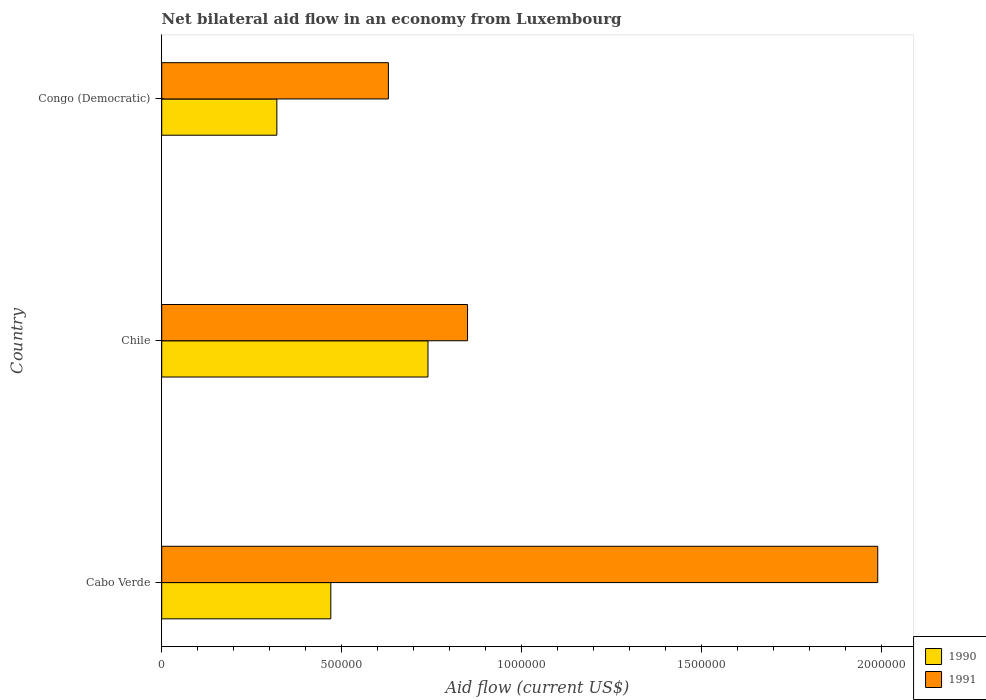How many different coloured bars are there?
Offer a very short reply. 2. How many groups of bars are there?
Your answer should be very brief. 3. How many bars are there on the 3rd tick from the bottom?
Keep it short and to the point. 2. What is the label of the 1st group of bars from the top?
Give a very brief answer. Congo (Democratic). What is the net bilateral aid flow in 1990 in Congo (Democratic)?
Your response must be concise. 3.20e+05. Across all countries, what is the maximum net bilateral aid flow in 1990?
Your answer should be very brief. 7.40e+05. Across all countries, what is the minimum net bilateral aid flow in 1990?
Ensure brevity in your answer.  3.20e+05. In which country was the net bilateral aid flow in 1991 maximum?
Offer a very short reply. Cabo Verde. In which country was the net bilateral aid flow in 1990 minimum?
Ensure brevity in your answer.  Congo (Democratic). What is the total net bilateral aid flow in 1990 in the graph?
Keep it short and to the point. 1.53e+06. What is the difference between the net bilateral aid flow in 1991 in Chile and that in Congo (Democratic)?
Your answer should be compact. 2.20e+05. What is the difference between the net bilateral aid flow in 1991 in Chile and the net bilateral aid flow in 1990 in Congo (Democratic)?
Offer a terse response. 5.30e+05. What is the average net bilateral aid flow in 1991 per country?
Keep it short and to the point. 1.16e+06. What is the difference between the net bilateral aid flow in 1991 and net bilateral aid flow in 1990 in Cabo Verde?
Offer a very short reply. 1.52e+06. What is the ratio of the net bilateral aid flow in 1990 in Cabo Verde to that in Chile?
Make the answer very short. 0.64. Is the net bilateral aid flow in 1990 in Cabo Verde less than that in Chile?
Your response must be concise. Yes. What is the difference between the highest and the second highest net bilateral aid flow in 1990?
Keep it short and to the point. 2.70e+05. What is the difference between the highest and the lowest net bilateral aid flow in 1990?
Make the answer very short. 4.20e+05. Is the sum of the net bilateral aid flow in 1991 in Cabo Verde and Chile greater than the maximum net bilateral aid flow in 1990 across all countries?
Offer a terse response. Yes. What does the 1st bar from the bottom in Cabo Verde represents?
Provide a succinct answer. 1990. How many bars are there?
Offer a very short reply. 6. Are all the bars in the graph horizontal?
Offer a very short reply. Yes. What is the difference between two consecutive major ticks on the X-axis?
Your response must be concise. 5.00e+05. Are the values on the major ticks of X-axis written in scientific E-notation?
Provide a short and direct response. No. Does the graph contain grids?
Keep it short and to the point. No. What is the title of the graph?
Provide a succinct answer. Net bilateral aid flow in an economy from Luxembourg. What is the label or title of the X-axis?
Make the answer very short. Aid flow (current US$). What is the Aid flow (current US$) of 1990 in Cabo Verde?
Your answer should be very brief. 4.70e+05. What is the Aid flow (current US$) of 1991 in Cabo Verde?
Offer a very short reply. 1.99e+06. What is the Aid flow (current US$) of 1990 in Chile?
Provide a succinct answer. 7.40e+05. What is the Aid flow (current US$) of 1991 in Chile?
Your answer should be very brief. 8.50e+05. What is the Aid flow (current US$) in 1991 in Congo (Democratic)?
Your answer should be compact. 6.30e+05. Across all countries, what is the maximum Aid flow (current US$) of 1990?
Keep it short and to the point. 7.40e+05. Across all countries, what is the maximum Aid flow (current US$) in 1991?
Keep it short and to the point. 1.99e+06. Across all countries, what is the minimum Aid flow (current US$) in 1991?
Offer a very short reply. 6.30e+05. What is the total Aid flow (current US$) in 1990 in the graph?
Your answer should be very brief. 1.53e+06. What is the total Aid flow (current US$) of 1991 in the graph?
Keep it short and to the point. 3.47e+06. What is the difference between the Aid flow (current US$) of 1990 in Cabo Verde and that in Chile?
Offer a very short reply. -2.70e+05. What is the difference between the Aid flow (current US$) of 1991 in Cabo Verde and that in Chile?
Your response must be concise. 1.14e+06. What is the difference between the Aid flow (current US$) of 1990 in Cabo Verde and that in Congo (Democratic)?
Ensure brevity in your answer.  1.50e+05. What is the difference between the Aid flow (current US$) of 1991 in Cabo Verde and that in Congo (Democratic)?
Offer a very short reply. 1.36e+06. What is the difference between the Aid flow (current US$) of 1990 in Chile and that in Congo (Democratic)?
Provide a succinct answer. 4.20e+05. What is the difference between the Aid flow (current US$) in 1990 in Cabo Verde and the Aid flow (current US$) in 1991 in Chile?
Your answer should be compact. -3.80e+05. What is the average Aid flow (current US$) in 1990 per country?
Offer a very short reply. 5.10e+05. What is the average Aid flow (current US$) in 1991 per country?
Offer a terse response. 1.16e+06. What is the difference between the Aid flow (current US$) of 1990 and Aid flow (current US$) of 1991 in Cabo Verde?
Your answer should be compact. -1.52e+06. What is the difference between the Aid flow (current US$) of 1990 and Aid flow (current US$) of 1991 in Chile?
Offer a very short reply. -1.10e+05. What is the difference between the Aid flow (current US$) of 1990 and Aid flow (current US$) of 1991 in Congo (Democratic)?
Provide a short and direct response. -3.10e+05. What is the ratio of the Aid flow (current US$) in 1990 in Cabo Verde to that in Chile?
Your response must be concise. 0.64. What is the ratio of the Aid flow (current US$) of 1991 in Cabo Verde to that in Chile?
Offer a very short reply. 2.34. What is the ratio of the Aid flow (current US$) of 1990 in Cabo Verde to that in Congo (Democratic)?
Your answer should be very brief. 1.47. What is the ratio of the Aid flow (current US$) in 1991 in Cabo Verde to that in Congo (Democratic)?
Keep it short and to the point. 3.16. What is the ratio of the Aid flow (current US$) of 1990 in Chile to that in Congo (Democratic)?
Your answer should be very brief. 2.31. What is the ratio of the Aid flow (current US$) of 1991 in Chile to that in Congo (Democratic)?
Give a very brief answer. 1.35. What is the difference between the highest and the second highest Aid flow (current US$) of 1990?
Offer a very short reply. 2.70e+05. What is the difference between the highest and the second highest Aid flow (current US$) in 1991?
Give a very brief answer. 1.14e+06. What is the difference between the highest and the lowest Aid flow (current US$) in 1991?
Provide a short and direct response. 1.36e+06. 